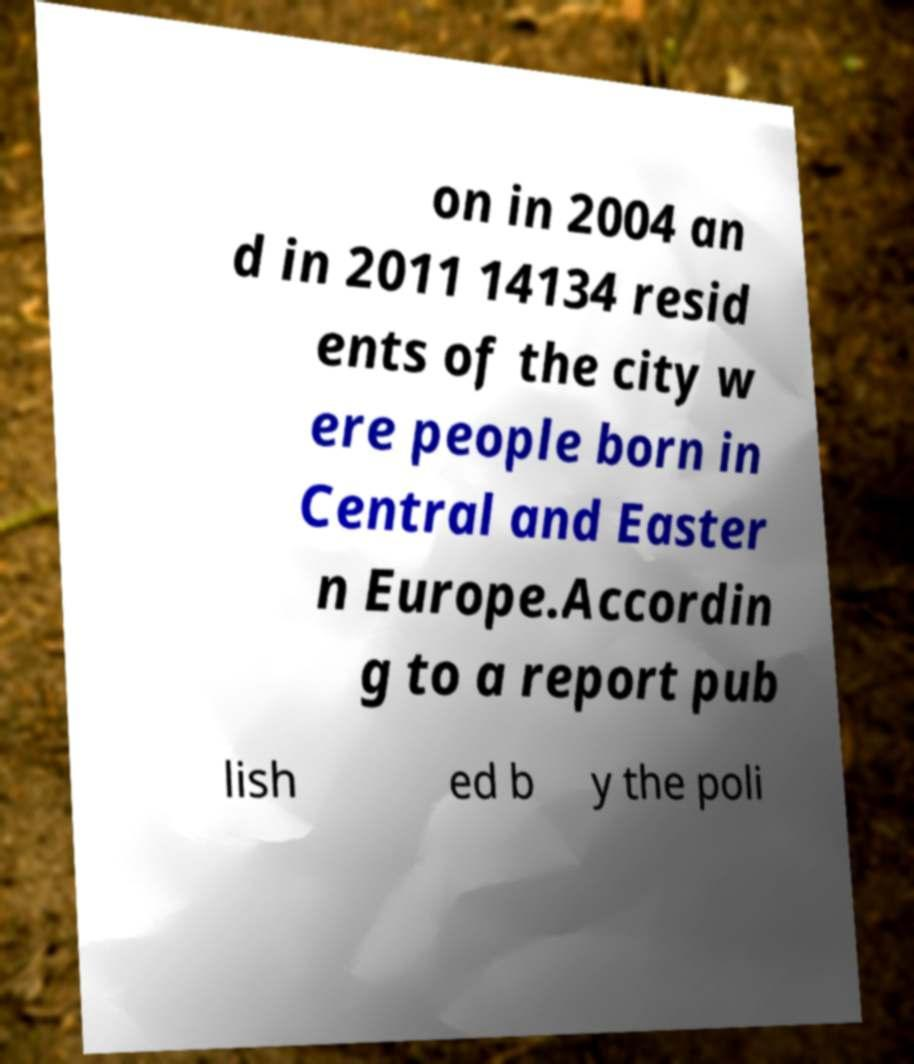What messages or text are displayed in this image? I need them in a readable, typed format. on in 2004 an d in 2011 14134 resid ents of the city w ere people born in Central and Easter n Europe.Accordin g to a report pub lish ed b y the poli 